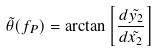Convert formula to latex. <formula><loc_0><loc_0><loc_500><loc_500>\tilde { \theta } ( f _ { P } ) = \arctan \left [ \frac { d \tilde { y _ { 2 } } } { d \tilde { x _ { 2 } } } \right ]</formula> 